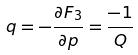<formula> <loc_0><loc_0><loc_500><loc_500>q = - \frac { \partial F _ { 3 } } { \partial p } = \frac { - 1 } { Q }</formula> 